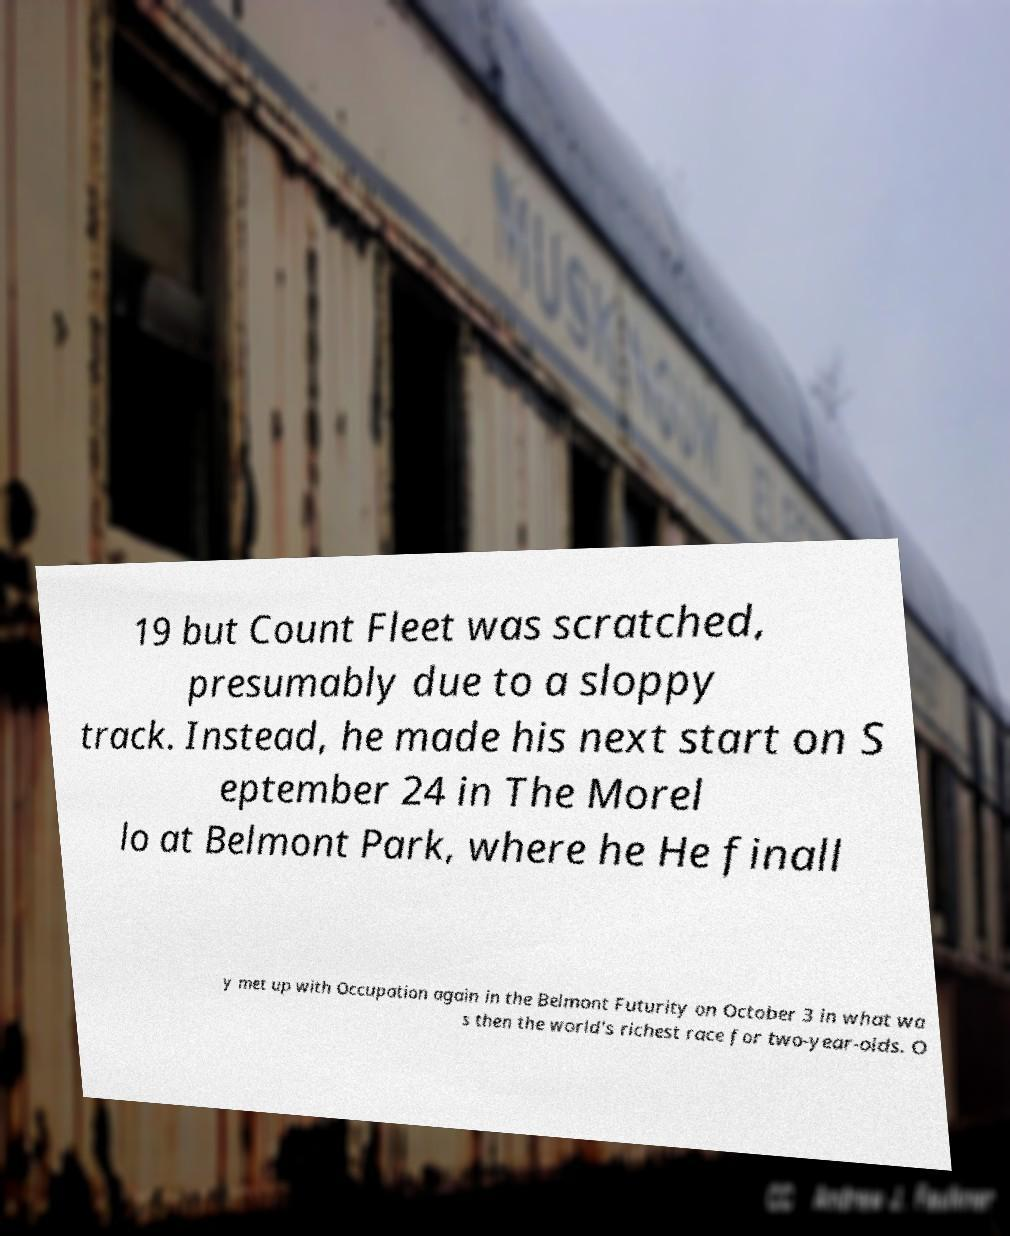Please read and relay the text visible in this image. What does it say? 19 but Count Fleet was scratched, presumably due to a sloppy track. Instead, he made his next start on S eptember 24 in The Morel lo at Belmont Park, where he He finall y met up with Occupation again in the Belmont Futurity on October 3 in what wa s then the world's richest race for two-year-olds. O 